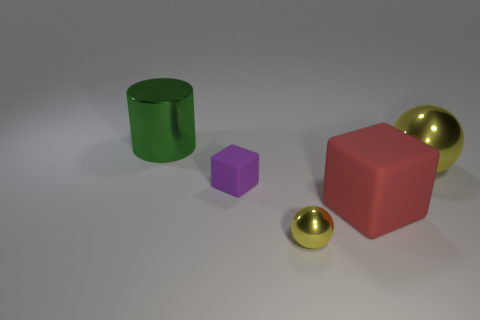There is a small object that is made of the same material as the large yellow ball; what is its color?
Provide a short and direct response. Yellow. What number of cylinders have the same size as the purple block?
Give a very brief answer. 0. What number of other things are there of the same color as the small matte thing?
Provide a succinct answer. 0. Is there anything else that is the same size as the cylinder?
Your answer should be compact. Yes. Does the large thing behind the large yellow sphere have the same shape as the yellow thing behind the large matte cube?
Provide a short and direct response. No. There is another metal object that is the same size as the green metallic object; what is its shape?
Offer a very short reply. Sphere. Is the number of purple matte blocks right of the tiny cube the same as the number of yellow metallic balls behind the green shiny cylinder?
Give a very brief answer. Yes. Is there anything else that is the same shape as the purple rubber thing?
Your answer should be very brief. Yes. Is the material of the yellow object that is in front of the big yellow thing the same as the red cube?
Offer a very short reply. No. There is a ball that is the same size as the purple rubber object; what is its material?
Offer a terse response. Metal. 